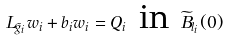Convert formula to latex. <formula><loc_0><loc_0><loc_500><loc_500>L _ { \tilde { g } _ { i } } w _ { i } + b _ { i } w _ { i } = Q _ { i } \text { in } \widetilde { B } _ { l _ { i } } ( 0 )</formula> 